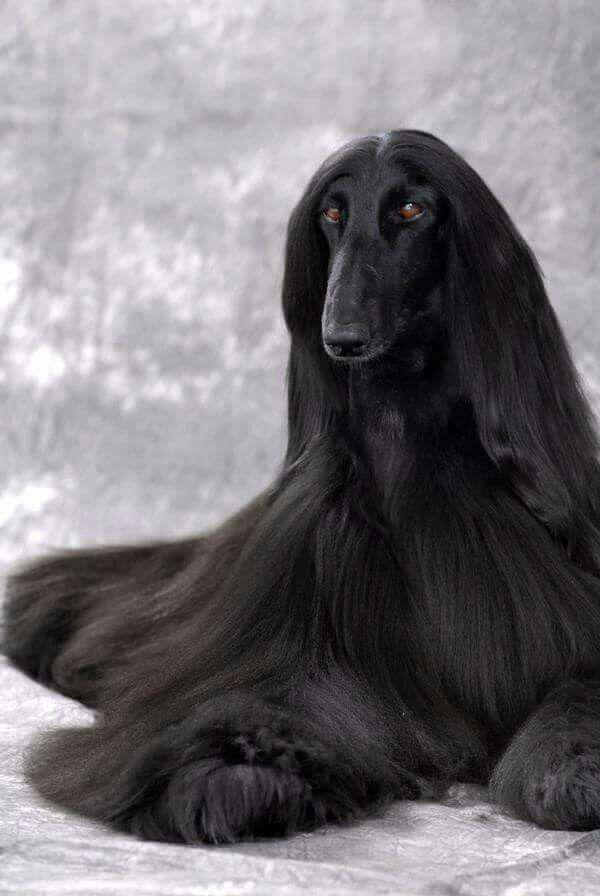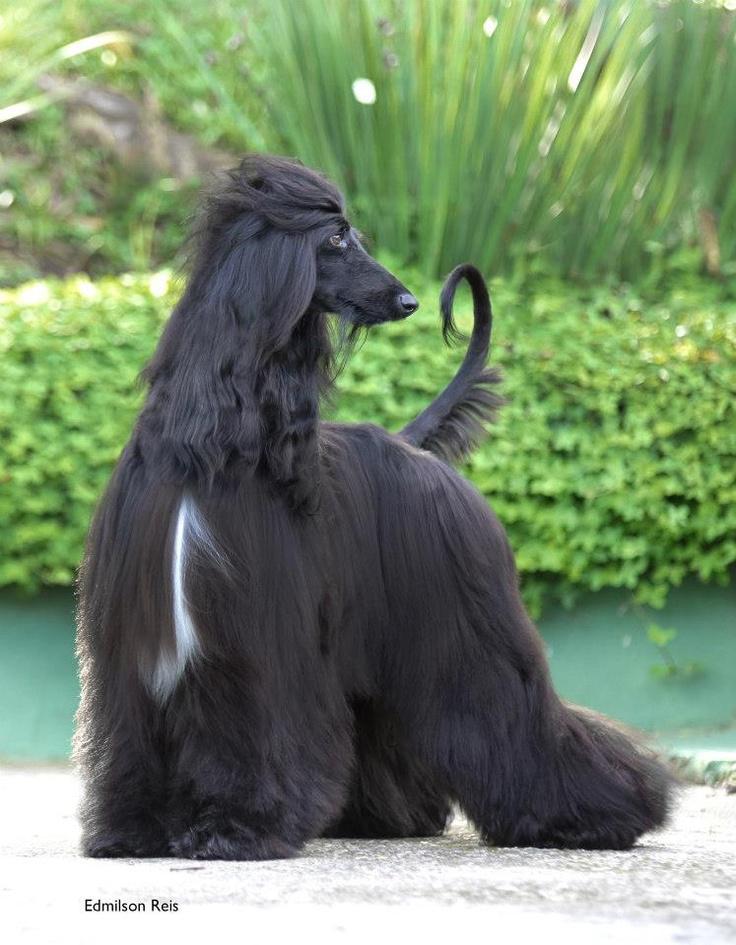The first image is the image on the left, the second image is the image on the right. Evaluate the accuracy of this statement regarding the images: "Each image contains a black afghan hound, and the right image shows a hound standing with its body in profile.". Is it true? Answer yes or no. Yes. The first image is the image on the left, the second image is the image on the right. Examine the images to the left and right. Is the description "One of the images has a black dog with long hair standing up." accurate? Answer yes or no. Yes. 